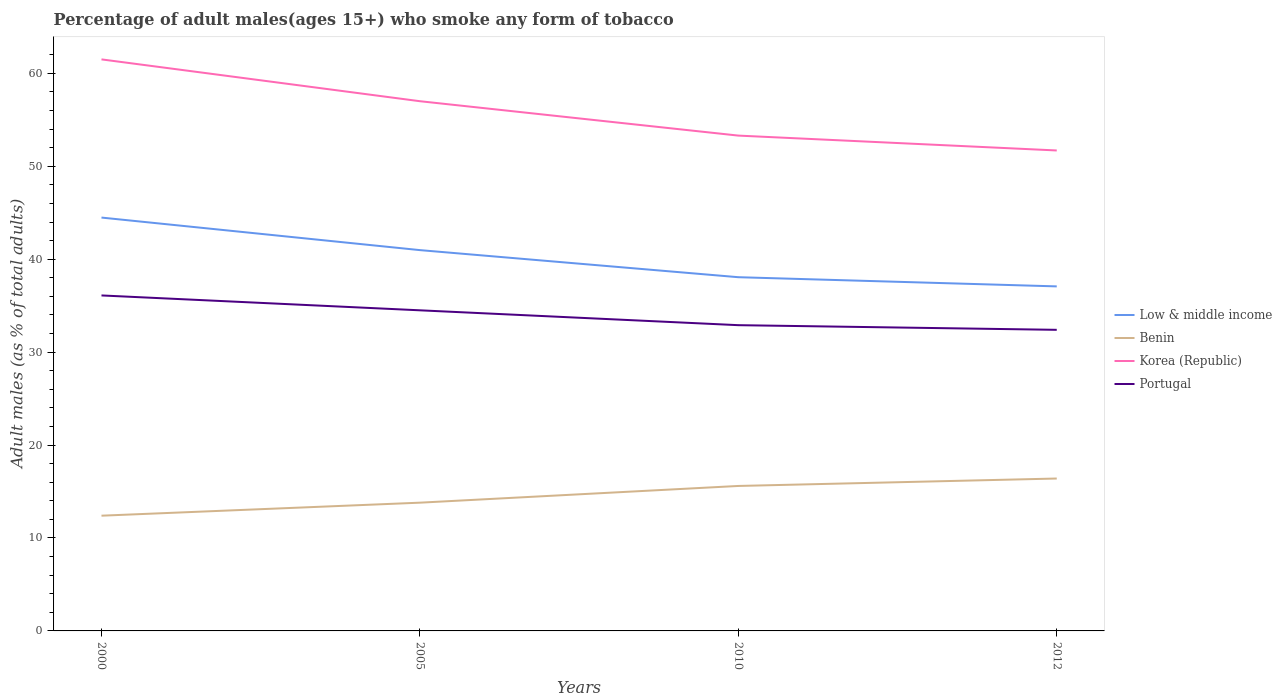Does the line corresponding to Low & middle income intersect with the line corresponding to Portugal?
Keep it short and to the point. No. Across all years, what is the maximum percentage of adult males who smoke in Portugal?
Your answer should be very brief. 32.4. What is the total percentage of adult males who smoke in Portugal in the graph?
Your answer should be compact. 3.2. What is the difference between the highest and the second highest percentage of adult males who smoke in Korea (Republic)?
Your answer should be compact. 9.8. Is the percentage of adult males who smoke in Benin strictly greater than the percentage of adult males who smoke in Low & middle income over the years?
Ensure brevity in your answer.  Yes. Does the graph contain any zero values?
Make the answer very short. No. Does the graph contain grids?
Keep it short and to the point. No. Where does the legend appear in the graph?
Make the answer very short. Center right. How many legend labels are there?
Offer a terse response. 4. What is the title of the graph?
Make the answer very short. Percentage of adult males(ages 15+) who smoke any form of tobacco. What is the label or title of the Y-axis?
Ensure brevity in your answer.  Adult males (as % of total adults). What is the Adult males (as % of total adults) of Low & middle income in 2000?
Provide a short and direct response. 44.48. What is the Adult males (as % of total adults) in Benin in 2000?
Your response must be concise. 12.4. What is the Adult males (as % of total adults) of Korea (Republic) in 2000?
Provide a succinct answer. 61.5. What is the Adult males (as % of total adults) of Portugal in 2000?
Offer a very short reply. 36.1. What is the Adult males (as % of total adults) of Low & middle income in 2005?
Your response must be concise. 40.98. What is the Adult males (as % of total adults) in Korea (Republic) in 2005?
Keep it short and to the point. 57. What is the Adult males (as % of total adults) in Portugal in 2005?
Your answer should be very brief. 34.5. What is the Adult males (as % of total adults) in Low & middle income in 2010?
Make the answer very short. 38.06. What is the Adult males (as % of total adults) of Korea (Republic) in 2010?
Your answer should be compact. 53.3. What is the Adult males (as % of total adults) in Portugal in 2010?
Your answer should be very brief. 32.9. What is the Adult males (as % of total adults) in Low & middle income in 2012?
Provide a short and direct response. 37.07. What is the Adult males (as % of total adults) in Benin in 2012?
Make the answer very short. 16.4. What is the Adult males (as % of total adults) in Korea (Republic) in 2012?
Make the answer very short. 51.7. What is the Adult males (as % of total adults) in Portugal in 2012?
Offer a terse response. 32.4. Across all years, what is the maximum Adult males (as % of total adults) in Low & middle income?
Provide a short and direct response. 44.48. Across all years, what is the maximum Adult males (as % of total adults) of Korea (Republic)?
Ensure brevity in your answer.  61.5. Across all years, what is the maximum Adult males (as % of total adults) in Portugal?
Your response must be concise. 36.1. Across all years, what is the minimum Adult males (as % of total adults) of Low & middle income?
Your response must be concise. 37.07. Across all years, what is the minimum Adult males (as % of total adults) in Benin?
Offer a very short reply. 12.4. Across all years, what is the minimum Adult males (as % of total adults) of Korea (Republic)?
Your answer should be very brief. 51.7. Across all years, what is the minimum Adult males (as % of total adults) of Portugal?
Provide a succinct answer. 32.4. What is the total Adult males (as % of total adults) in Low & middle income in the graph?
Make the answer very short. 160.59. What is the total Adult males (as % of total adults) in Benin in the graph?
Provide a short and direct response. 58.2. What is the total Adult males (as % of total adults) of Korea (Republic) in the graph?
Offer a very short reply. 223.5. What is the total Adult males (as % of total adults) in Portugal in the graph?
Give a very brief answer. 135.9. What is the difference between the Adult males (as % of total adults) in Low & middle income in 2000 and that in 2005?
Provide a short and direct response. 3.5. What is the difference between the Adult males (as % of total adults) of Benin in 2000 and that in 2005?
Keep it short and to the point. -1.4. What is the difference between the Adult males (as % of total adults) of Korea (Republic) in 2000 and that in 2005?
Your answer should be very brief. 4.5. What is the difference between the Adult males (as % of total adults) in Low & middle income in 2000 and that in 2010?
Your answer should be compact. 6.42. What is the difference between the Adult males (as % of total adults) in Portugal in 2000 and that in 2010?
Your answer should be very brief. 3.2. What is the difference between the Adult males (as % of total adults) of Low & middle income in 2000 and that in 2012?
Make the answer very short. 7.41. What is the difference between the Adult males (as % of total adults) of Low & middle income in 2005 and that in 2010?
Provide a succinct answer. 2.91. What is the difference between the Adult males (as % of total adults) in Benin in 2005 and that in 2010?
Keep it short and to the point. -1.8. What is the difference between the Adult males (as % of total adults) in Low & middle income in 2005 and that in 2012?
Offer a very short reply. 3.9. What is the difference between the Adult males (as % of total adults) in Benin in 2005 and that in 2012?
Make the answer very short. -2.6. What is the difference between the Adult males (as % of total adults) in Korea (Republic) in 2005 and that in 2012?
Offer a terse response. 5.3. What is the difference between the Adult males (as % of total adults) of Portugal in 2005 and that in 2012?
Ensure brevity in your answer.  2.1. What is the difference between the Adult males (as % of total adults) in Korea (Republic) in 2010 and that in 2012?
Ensure brevity in your answer.  1.6. What is the difference between the Adult males (as % of total adults) in Portugal in 2010 and that in 2012?
Your answer should be very brief. 0.5. What is the difference between the Adult males (as % of total adults) in Low & middle income in 2000 and the Adult males (as % of total adults) in Benin in 2005?
Your response must be concise. 30.68. What is the difference between the Adult males (as % of total adults) in Low & middle income in 2000 and the Adult males (as % of total adults) in Korea (Republic) in 2005?
Provide a short and direct response. -12.52. What is the difference between the Adult males (as % of total adults) in Low & middle income in 2000 and the Adult males (as % of total adults) in Portugal in 2005?
Offer a very short reply. 9.98. What is the difference between the Adult males (as % of total adults) of Benin in 2000 and the Adult males (as % of total adults) of Korea (Republic) in 2005?
Give a very brief answer. -44.6. What is the difference between the Adult males (as % of total adults) in Benin in 2000 and the Adult males (as % of total adults) in Portugal in 2005?
Provide a succinct answer. -22.1. What is the difference between the Adult males (as % of total adults) of Low & middle income in 2000 and the Adult males (as % of total adults) of Benin in 2010?
Offer a very short reply. 28.88. What is the difference between the Adult males (as % of total adults) of Low & middle income in 2000 and the Adult males (as % of total adults) of Korea (Republic) in 2010?
Your response must be concise. -8.82. What is the difference between the Adult males (as % of total adults) in Low & middle income in 2000 and the Adult males (as % of total adults) in Portugal in 2010?
Offer a very short reply. 11.58. What is the difference between the Adult males (as % of total adults) of Benin in 2000 and the Adult males (as % of total adults) of Korea (Republic) in 2010?
Make the answer very short. -40.9. What is the difference between the Adult males (as % of total adults) in Benin in 2000 and the Adult males (as % of total adults) in Portugal in 2010?
Offer a terse response. -20.5. What is the difference between the Adult males (as % of total adults) in Korea (Republic) in 2000 and the Adult males (as % of total adults) in Portugal in 2010?
Make the answer very short. 28.6. What is the difference between the Adult males (as % of total adults) of Low & middle income in 2000 and the Adult males (as % of total adults) of Benin in 2012?
Your answer should be very brief. 28.08. What is the difference between the Adult males (as % of total adults) in Low & middle income in 2000 and the Adult males (as % of total adults) in Korea (Republic) in 2012?
Provide a succinct answer. -7.22. What is the difference between the Adult males (as % of total adults) of Low & middle income in 2000 and the Adult males (as % of total adults) of Portugal in 2012?
Your answer should be compact. 12.08. What is the difference between the Adult males (as % of total adults) of Benin in 2000 and the Adult males (as % of total adults) of Korea (Republic) in 2012?
Keep it short and to the point. -39.3. What is the difference between the Adult males (as % of total adults) in Korea (Republic) in 2000 and the Adult males (as % of total adults) in Portugal in 2012?
Your answer should be compact. 29.1. What is the difference between the Adult males (as % of total adults) in Low & middle income in 2005 and the Adult males (as % of total adults) in Benin in 2010?
Your answer should be very brief. 25.38. What is the difference between the Adult males (as % of total adults) in Low & middle income in 2005 and the Adult males (as % of total adults) in Korea (Republic) in 2010?
Make the answer very short. -12.32. What is the difference between the Adult males (as % of total adults) in Low & middle income in 2005 and the Adult males (as % of total adults) in Portugal in 2010?
Your response must be concise. 8.08. What is the difference between the Adult males (as % of total adults) of Benin in 2005 and the Adult males (as % of total adults) of Korea (Republic) in 2010?
Offer a terse response. -39.5. What is the difference between the Adult males (as % of total adults) of Benin in 2005 and the Adult males (as % of total adults) of Portugal in 2010?
Provide a succinct answer. -19.1. What is the difference between the Adult males (as % of total adults) of Korea (Republic) in 2005 and the Adult males (as % of total adults) of Portugal in 2010?
Your response must be concise. 24.1. What is the difference between the Adult males (as % of total adults) in Low & middle income in 2005 and the Adult males (as % of total adults) in Benin in 2012?
Keep it short and to the point. 24.58. What is the difference between the Adult males (as % of total adults) in Low & middle income in 2005 and the Adult males (as % of total adults) in Korea (Republic) in 2012?
Make the answer very short. -10.72. What is the difference between the Adult males (as % of total adults) of Low & middle income in 2005 and the Adult males (as % of total adults) of Portugal in 2012?
Offer a terse response. 8.58. What is the difference between the Adult males (as % of total adults) of Benin in 2005 and the Adult males (as % of total adults) of Korea (Republic) in 2012?
Offer a very short reply. -37.9. What is the difference between the Adult males (as % of total adults) in Benin in 2005 and the Adult males (as % of total adults) in Portugal in 2012?
Give a very brief answer. -18.6. What is the difference between the Adult males (as % of total adults) of Korea (Republic) in 2005 and the Adult males (as % of total adults) of Portugal in 2012?
Ensure brevity in your answer.  24.6. What is the difference between the Adult males (as % of total adults) of Low & middle income in 2010 and the Adult males (as % of total adults) of Benin in 2012?
Ensure brevity in your answer.  21.66. What is the difference between the Adult males (as % of total adults) in Low & middle income in 2010 and the Adult males (as % of total adults) in Korea (Republic) in 2012?
Offer a terse response. -13.64. What is the difference between the Adult males (as % of total adults) in Low & middle income in 2010 and the Adult males (as % of total adults) in Portugal in 2012?
Your answer should be compact. 5.66. What is the difference between the Adult males (as % of total adults) of Benin in 2010 and the Adult males (as % of total adults) of Korea (Republic) in 2012?
Provide a succinct answer. -36.1. What is the difference between the Adult males (as % of total adults) of Benin in 2010 and the Adult males (as % of total adults) of Portugal in 2012?
Offer a very short reply. -16.8. What is the difference between the Adult males (as % of total adults) of Korea (Republic) in 2010 and the Adult males (as % of total adults) of Portugal in 2012?
Your answer should be very brief. 20.9. What is the average Adult males (as % of total adults) of Low & middle income per year?
Offer a very short reply. 40.15. What is the average Adult males (as % of total adults) in Benin per year?
Offer a terse response. 14.55. What is the average Adult males (as % of total adults) in Korea (Republic) per year?
Make the answer very short. 55.88. What is the average Adult males (as % of total adults) in Portugal per year?
Offer a very short reply. 33.98. In the year 2000, what is the difference between the Adult males (as % of total adults) of Low & middle income and Adult males (as % of total adults) of Benin?
Give a very brief answer. 32.08. In the year 2000, what is the difference between the Adult males (as % of total adults) of Low & middle income and Adult males (as % of total adults) of Korea (Republic)?
Your response must be concise. -17.02. In the year 2000, what is the difference between the Adult males (as % of total adults) of Low & middle income and Adult males (as % of total adults) of Portugal?
Ensure brevity in your answer.  8.38. In the year 2000, what is the difference between the Adult males (as % of total adults) in Benin and Adult males (as % of total adults) in Korea (Republic)?
Your answer should be compact. -49.1. In the year 2000, what is the difference between the Adult males (as % of total adults) in Benin and Adult males (as % of total adults) in Portugal?
Give a very brief answer. -23.7. In the year 2000, what is the difference between the Adult males (as % of total adults) in Korea (Republic) and Adult males (as % of total adults) in Portugal?
Make the answer very short. 25.4. In the year 2005, what is the difference between the Adult males (as % of total adults) in Low & middle income and Adult males (as % of total adults) in Benin?
Ensure brevity in your answer.  27.18. In the year 2005, what is the difference between the Adult males (as % of total adults) in Low & middle income and Adult males (as % of total adults) in Korea (Republic)?
Your answer should be very brief. -16.02. In the year 2005, what is the difference between the Adult males (as % of total adults) of Low & middle income and Adult males (as % of total adults) of Portugal?
Give a very brief answer. 6.48. In the year 2005, what is the difference between the Adult males (as % of total adults) of Benin and Adult males (as % of total adults) of Korea (Republic)?
Give a very brief answer. -43.2. In the year 2005, what is the difference between the Adult males (as % of total adults) of Benin and Adult males (as % of total adults) of Portugal?
Make the answer very short. -20.7. In the year 2005, what is the difference between the Adult males (as % of total adults) of Korea (Republic) and Adult males (as % of total adults) of Portugal?
Provide a succinct answer. 22.5. In the year 2010, what is the difference between the Adult males (as % of total adults) of Low & middle income and Adult males (as % of total adults) of Benin?
Offer a very short reply. 22.46. In the year 2010, what is the difference between the Adult males (as % of total adults) of Low & middle income and Adult males (as % of total adults) of Korea (Republic)?
Make the answer very short. -15.24. In the year 2010, what is the difference between the Adult males (as % of total adults) in Low & middle income and Adult males (as % of total adults) in Portugal?
Give a very brief answer. 5.16. In the year 2010, what is the difference between the Adult males (as % of total adults) of Benin and Adult males (as % of total adults) of Korea (Republic)?
Offer a terse response. -37.7. In the year 2010, what is the difference between the Adult males (as % of total adults) of Benin and Adult males (as % of total adults) of Portugal?
Your response must be concise. -17.3. In the year 2010, what is the difference between the Adult males (as % of total adults) of Korea (Republic) and Adult males (as % of total adults) of Portugal?
Make the answer very short. 20.4. In the year 2012, what is the difference between the Adult males (as % of total adults) of Low & middle income and Adult males (as % of total adults) of Benin?
Provide a short and direct response. 20.67. In the year 2012, what is the difference between the Adult males (as % of total adults) of Low & middle income and Adult males (as % of total adults) of Korea (Republic)?
Provide a short and direct response. -14.63. In the year 2012, what is the difference between the Adult males (as % of total adults) of Low & middle income and Adult males (as % of total adults) of Portugal?
Make the answer very short. 4.67. In the year 2012, what is the difference between the Adult males (as % of total adults) of Benin and Adult males (as % of total adults) of Korea (Republic)?
Provide a succinct answer. -35.3. In the year 2012, what is the difference between the Adult males (as % of total adults) of Benin and Adult males (as % of total adults) of Portugal?
Make the answer very short. -16. In the year 2012, what is the difference between the Adult males (as % of total adults) of Korea (Republic) and Adult males (as % of total adults) of Portugal?
Your answer should be very brief. 19.3. What is the ratio of the Adult males (as % of total adults) in Low & middle income in 2000 to that in 2005?
Provide a short and direct response. 1.09. What is the ratio of the Adult males (as % of total adults) in Benin in 2000 to that in 2005?
Give a very brief answer. 0.9. What is the ratio of the Adult males (as % of total adults) of Korea (Republic) in 2000 to that in 2005?
Ensure brevity in your answer.  1.08. What is the ratio of the Adult males (as % of total adults) of Portugal in 2000 to that in 2005?
Your answer should be very brief. 1.05. What is the ratio of the Adult males (as % of total adults) of Low & middle income in 2000 to that in 2010?
Give a very brief answer. 1.17. What is the ratio of the Adult males (as % of total adults) of Benin in 2000 to that in 2010?
Provide a succinct answer. 0.79. What is the ratio of the Adult males (as % of total adults) of Korea (Republic) in 2000 to that in 2010?
Your answer should be very brief. 1.15. What is the ratio of the Adult males (as % of total adults) of Portugal in 2000 to that in 2010?
Your answer should be compact. 1.1. What is the ratio of the Adult males (as % of total adults) of Low & middle income in 2000 to that in 2012?
Your answer should be compact. 1.2. What is the ratio of the Adult males (as % of total adults) in Benin in 2000 to that in 2012?
Keep it short and to the point. 0.76. What is the ratio of the Adult males (as % of total adults) in Korea (Republic) in 2000 to that in 2012?
Your answer should be very brief. 1.19. What is the ratio of the Adult males (as % of total adults) of Portugal in 2000 to that in 2012?
Your answer should be compact. 1.11. What is the ratio of the Adult males (as % of total adults) of Low & middle income in 2005 to that in 2010?
Your response must be concise. 1.08. What is the ratio of the Adult males (as % of total adults) of Benin in 2005 to that in 2010?
Ensure brevity in your answer.  0.88. What is the ratio of the Adult males (as % of total adults) in Korea (Republic) in 2005 to that in 2010?
Provide a succinct answer. 1.07. What is the ratio of the Adult males (as % of total adults) of Portugal in 2005 to that in 2010?
Keep it short and to the point. 1.05. What is the ratio of the Adult males (as % of total adults) in Low & middle income in 2005 to that in 2012?
Your answer should be compact. 1.11. What is the ratio of the Adult males (as % of total adults) in Benin in 2005 to that in 2012?
Give a very brief answer. 0.84. What is the ratio of the Adult males (as % of total adults) of Korea (Republic) in 2005 to that in 2012?
Make the answer very short. 1.1. What is the ratio of the Adult males (as % of total adults) of Portugal in 2005 to that in 2012?
Provide a succinct answer. 1.06. What is the ratio of the Adult males (as % of total adults) of Low & middle income in 2010 to that in 2012?
Ensure brevity in your answer.  1.03. What is the ratio of the Adult males (as % of total adults) in Benin in 2010 to that in 2012?
Provide a succinct answer. 0.95. What is the ratio of the Adult males (as % of total adults) in Korea (Republic) in 2010 to that in 2012?
Your response must be concise. 1.03. What is the ratio of the Adult males (as % of total adults) of Portugal in 2010 to that in 2012?
Ensure brevity in your answer.  1.02. What is the difference between the highest and the second highest Adult males (as % of total adults) of Low & middle income?
Offer a terse response. 3.5. What is the difference between the highest and the second highest Adult males (as % of total adults) in Korea (Republic)?
Ensure brevity in your answer.  4.5. What is the difference between the highest and the lowest Adult males (as % of total adults) of Low & middle income?
Provide a succinct answer. 7.41. What is the difference between the highest and the lowest Adult males (as % of total adults) of Korea (Republic)?
Provide a succinct answer. 9.8. What is the difference between the highest and the lowest Adult males (as % of total adults) in Portugal?
Offer a terse response. 3.7. 